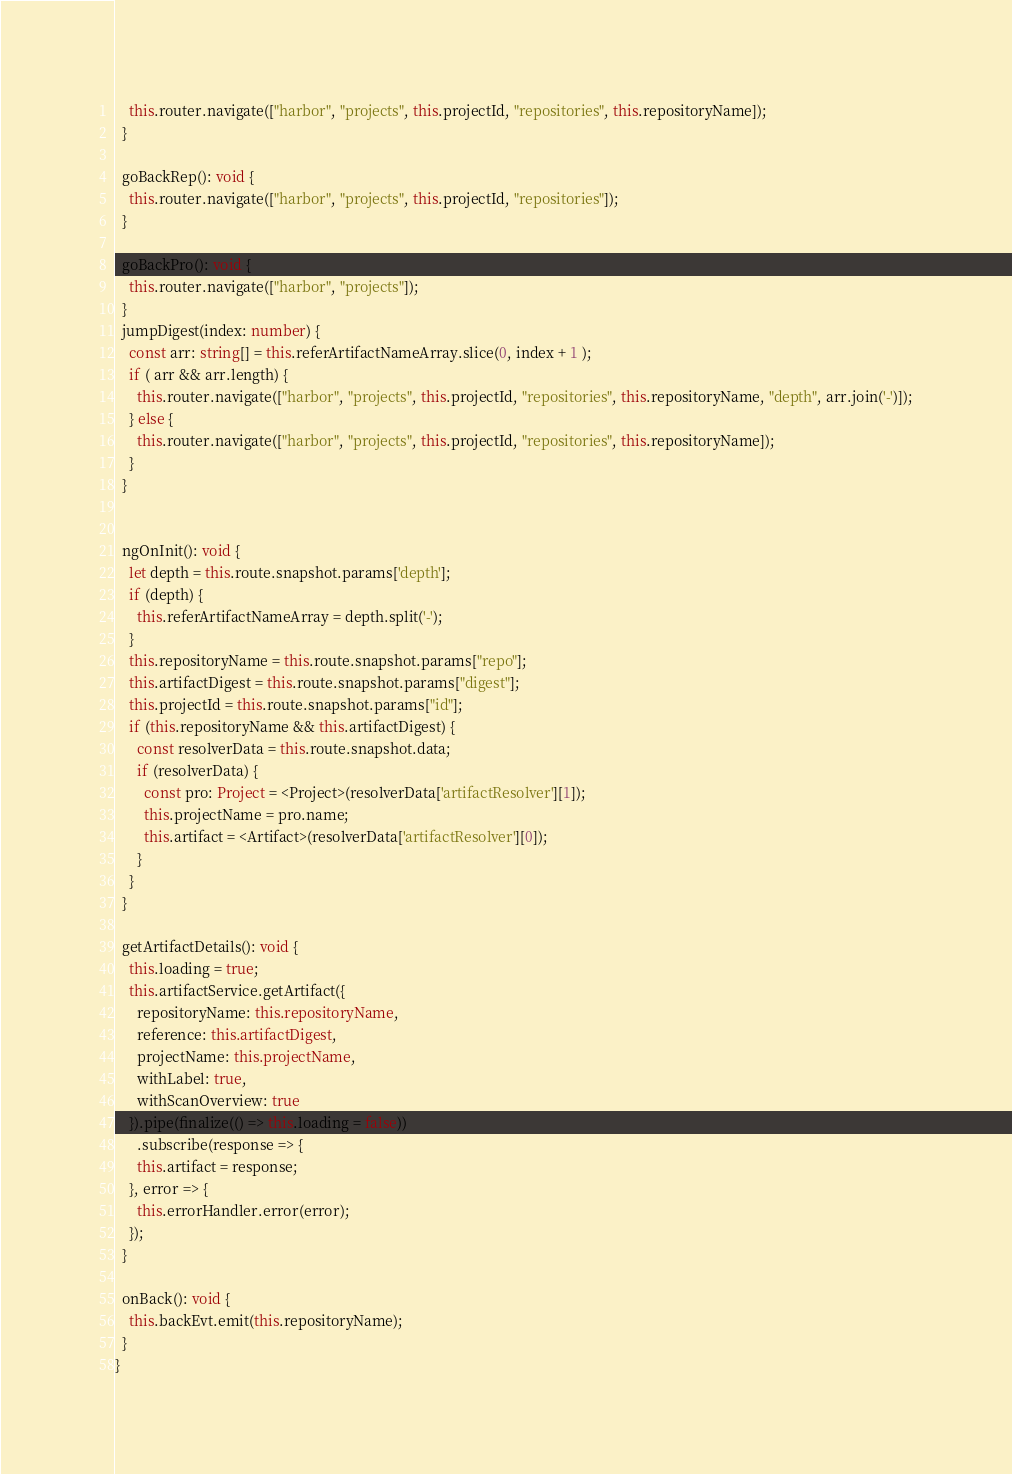<code> <loc_0><loc_0><loc_500><loc_500><_TypeScript_>    this.router.navigate(["harbor", "projects", this.projectId, "repositories", this.repositoryName]);
  }

  goBackRep(): void {
    this.router.navigate(["harbor", "projects", this.projectId, "repositories"]);
  }

  goBackPro(): void {
    this.router.navigate(["harbor", "projects"]);
  }
  jumpDigest(index: number) {
    const arr: string[] = this.referArtifactNameArray.slice(0, index + 1 );
    if ( arr && arr.length) {
      this.router.navigate(["harbor", "projects", this.projectId, "repositories", this.repositoryName, "depth", arr.join('-')]);
    } else {
      this.router.navigate(["harbor", "projects", this.projectId, "repositories", this.repositoryName]);
    }
  }


  ngOnInit(): void {
    let depth = this.route.snapshot.params['depth'];
    if (depth) {
      this.referArtifactNameArray = depth.split('-');
    }
    this.repositoryName = this.route.snapshot.params["repo"];
    this.artifactDigest = this.route.snapshot.params["digest"];
    this.projectId = this.route.snapshot.params["id"];
    if (this.repositoryName && this.artifactDigest) {
      const resolverData = this.route.snapshot.data;
      if (resolverData) {
        const pro: Project = <Project>(resolverData['artifactResolver'][1]);
        this.projectName = pro.name;
        this.artifact = <Artifact>(resolverData['artifactResolver'][0]);
      }
    }
  }

  getArtifactDetails(): void {
    this.loading = true;
    this.artifactService.getArtifact({
      repositoryName: this.repositoryName,
      reference: this.artifactDigest,
      projectName: this.projectName,
      withLabel: true,
      withScanOverview: true
    }).pipe(finalize(() => this.loading = false))
      .subscribe(response => {
      this.artifact = response;
    }, error => {
      this.errorHandler.error(error);
    });
  }

  onBack(): void {
    this.backEvt.emit(this.repositoryName);
  }
}
</code> 